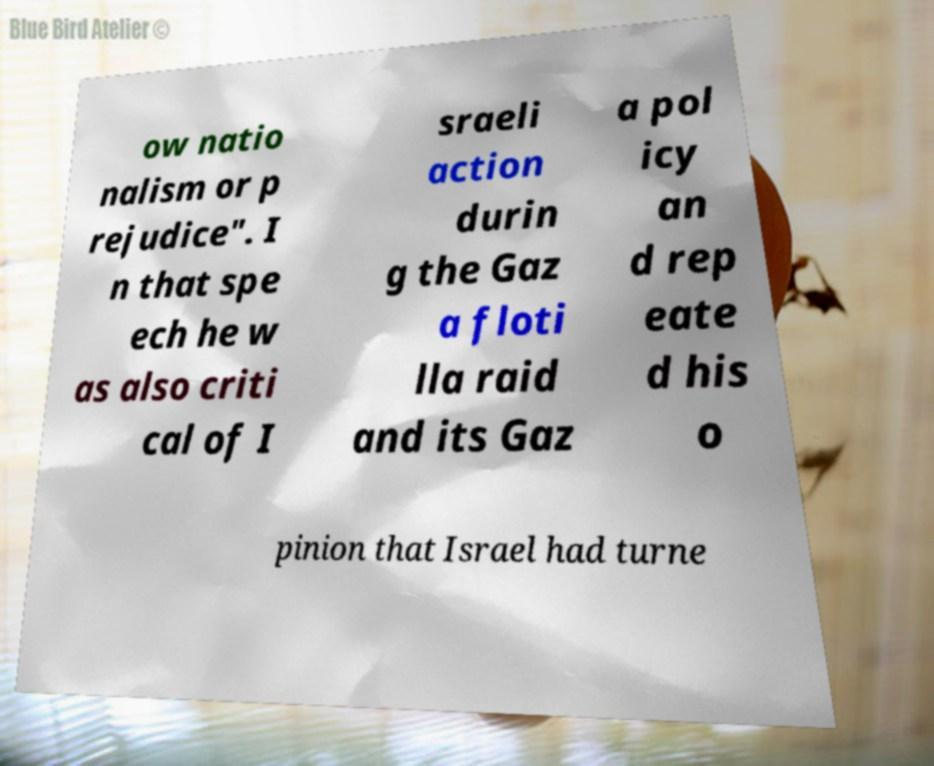What messages or text are displayed in this image? I need them in a readable, typed format. ow natio nalism or p rejudice". I n that spe ech he w as also criti cal of I sraeli action durin g the Gaz a floti lla raid and its Gaz a pol icy an d rep eate d his o pinion that Israel had turne 